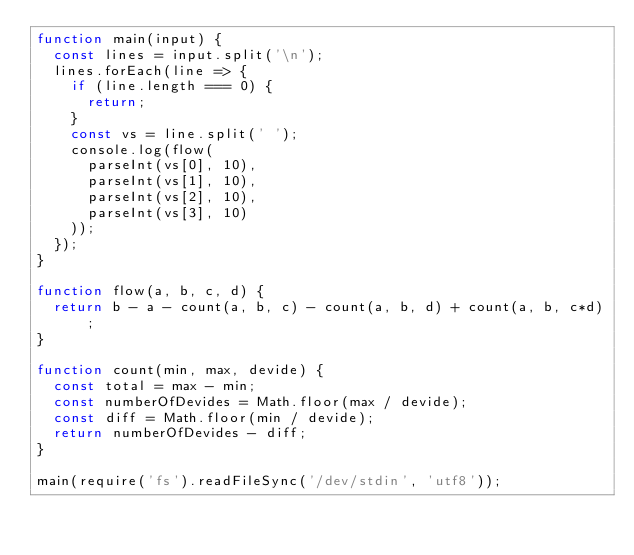Convert code to text. <code><loc_0><loc_0><loc_500><loc_500><_JavaScript_>function main(input) {
  const lines = input.split('\n');
  lines.forEach(line => {
    if (line.length === 0) {
      return;
    }
    const vs = line.split(' ');
    console.log(flow(
      parseInt(vs[0], 10),
      parseInt(vs[1], 10),
      parseInt(vs[2], 10),
      parseInt(vs[3], 10)
    ));
  });
}

function flow(a, b, c, d) {
  return b - a - count(a, b, c) - count(a, b, d) + count(a, b, c*d);
}

function count(min, max, devide) {
  const total = max - min;
  const numberOfDevides = Math.floor(max / devide);
  const diff = Math.floor(min / devide);
  return numberOfDevides - diff;
}

main(require('fs').readFileSync('/dev/stdin', 'utf8'));
</code> 